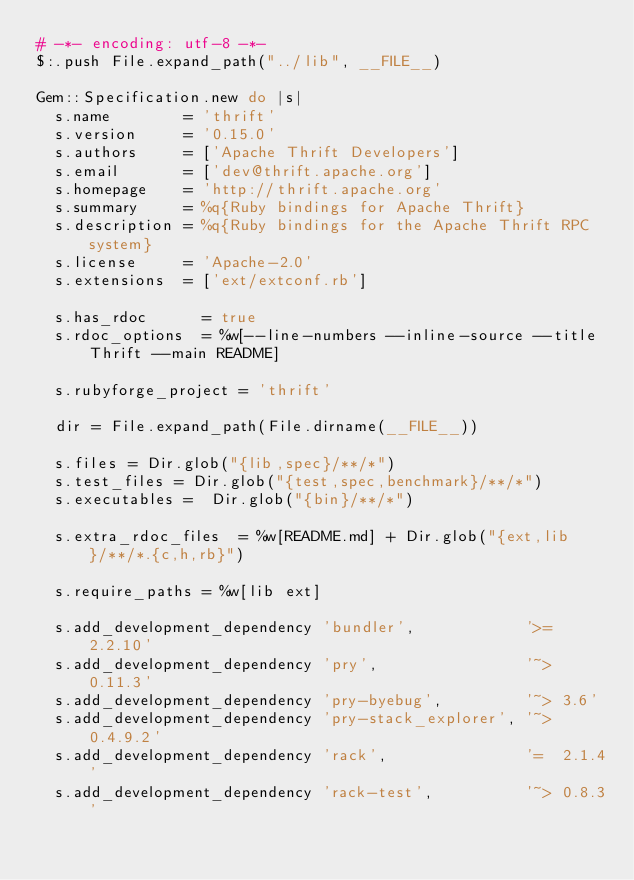Convert code to text. <code><loc_0><loc_0><loc_500><loc_500><_Ruby_># -*- encoding: utf-8 -*-
$:.push File.expand_path("../lib", __FILE__)

Gem::Specification.new do |s|
  s.name        = 'thrift'
  s.version     = '0.15.0'
  s.authors     = ['Apache Thrift Developers']
  s.email       = ['dev@thrift.apache.org']
  s.homepage    = 'http://thrift.apache.org'
  s.summary     = %q{Ruby bindings for Apache Thrift}
  s.description = %q{Ruby bindings for the Apache Thrift RPC system}
  s.license     = 'Apache-2.0'
  s.extensions  = ['ext/extconf.rb']

  s.has_rdoc      = true
  s.rdoc_options  = %w[--line-numbers --inline-source --title Thrift --main README]

  s.rubyforge_project = 'thrift'

  dir = File.expand_path(File.dirname(__FILE__))

  s.files = Dir.glob("{lib,spec}/**/*")
  s.test_files = Dir.glob("{test,spec,benchmark}/**/*")
  s.executables =  Dir.glob("{bin}/**/*")

  s.extra_rdoc_files  = %w[README.md] + Dir.glob("{ext,lib}/**/*.{c,h,rb}")

  s.require_paths = %w[lib ext]

  s.add_development_dependency 'bundler',            '>= 2.2.10'
  s.add_development_dependency 'pry',                '~> 0.11.3'
  s.add_development_dependency 'pry-byebug',         '~> 3.6'
  s.add_development_dependency 'pry-stack_explorer', '~> 0.4.9.2'
  s.add_development_dependency 'rack',               '=  2.1.4'
  s.add_development_dependency 'rack-test',          '~> 0.8.3'</code> 